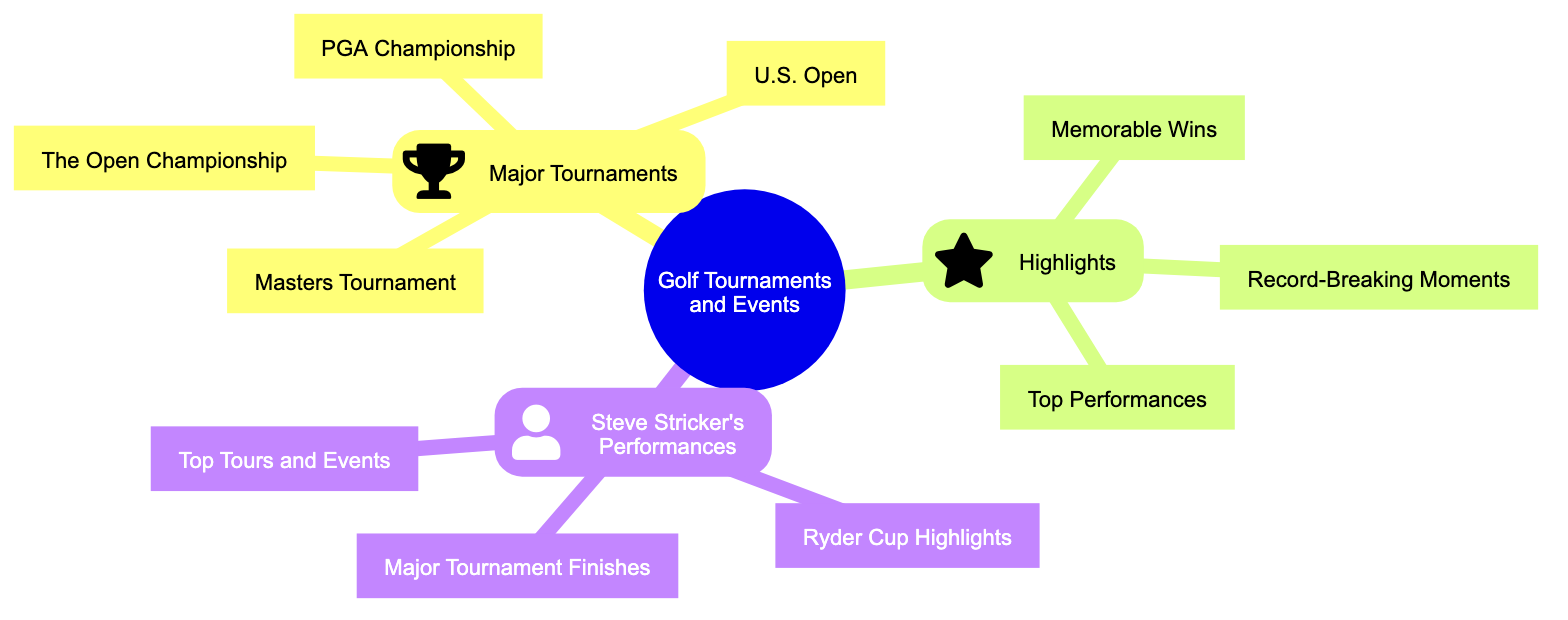What are the four major tournaments listed? The diagram indicates that the major tournaments include the Masters Tournament, PGA Championship, U.S. Open, and The Open Championship. This can be confirmed by examining the "Major Tournaments" subtopic, which lists these events directly.
Answer: Masters Tournament, PGA Championship, U.S. Open, The Open Championship How many highlights are mentioned? By counting the number of elements in the "Highlights" subtopic, we find there are three mentions: Memorable Wins, Record-Breaking Moments, and Top Performances. This can be derived from the visually displayed node structure under "Highlights."
Answer: 3 What performance highlights are featured for Steve Stricker? The performances for Steve Stricker are categorized as Ryder Cup Highlights, Major Tournament Finishes, and Top Tours and Events. This information is directly taken from the subtopic labeled "Steve Stricker’s Performances."
Answer: Ryder Cup Highlights, Major Tournament Finishes, Top Tours and Events Which major tournament is first in the list? The first item listed under the "Major Tournaments" subtopic is the Masters Tournament. This is assessed by looking at the order of the nodes displayed beneath this subtopic.
Answer: Masters Tournament How many total subtopics are there in the diagram? There are a total of three subtopics in the diagram: Major Tournaments, Highlights, and Steve Stricker's Performances. This can be confirmed by counting the main branches stemming from the root node.
Answer: 3 Which highlight refers to outstanding achievements in matches? The highlight that refers to outstanding achievements in matches is "Top Performances." This is concluded by looking at the context of the highlights listed and understanding that it implies significant displays of skill.
Answer: Top Performances What is the relationship between Steve Stricker and the highlights? The relationship is that the highlights specifically pertain to Stricker's performances, which include events like Ryder Cup Highlights and Major Tournament Finishes. This can be reasoned by noting that all elements under "Steve Stricker’s Performances" relate directly to highlights of his career.
Answer: Related How many nodes does the "Steve Stricker’s Performances" subtopic have? The "Steve Stricker's Performances" subtopic contains three nodes: Ryder Cup Highlights, Major Tournament Finishes, and Top Tours and Events. By simply counting the elements under this specific subtopic, the total can be determined.
Answer: 3 